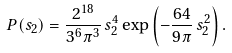<formula> <loc_0><loc_0><loc_500><loc_500>P ( s _ { 2 } ) = \frac { 2 ^ { 1 8 } } { 3 ^ { 6 } \pi ^ { 3 } } \, s _ { 2 } ^ { 4 } \exp \left ( - \frac { 6 4 } { 9 \pi } \, s _ { 2 } ^ { 2 } \right ) .</formula> 